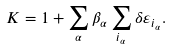Convert formula to latex. <formula><loc_0><loc_0><loc_500><loc_500>K = 1 + \sum _ { \alpha } \beta _ { \alpha } \sum _ { i _ { \alpha } } \delta \varepsilon _ { i _ { \alpha } } .</formula> 